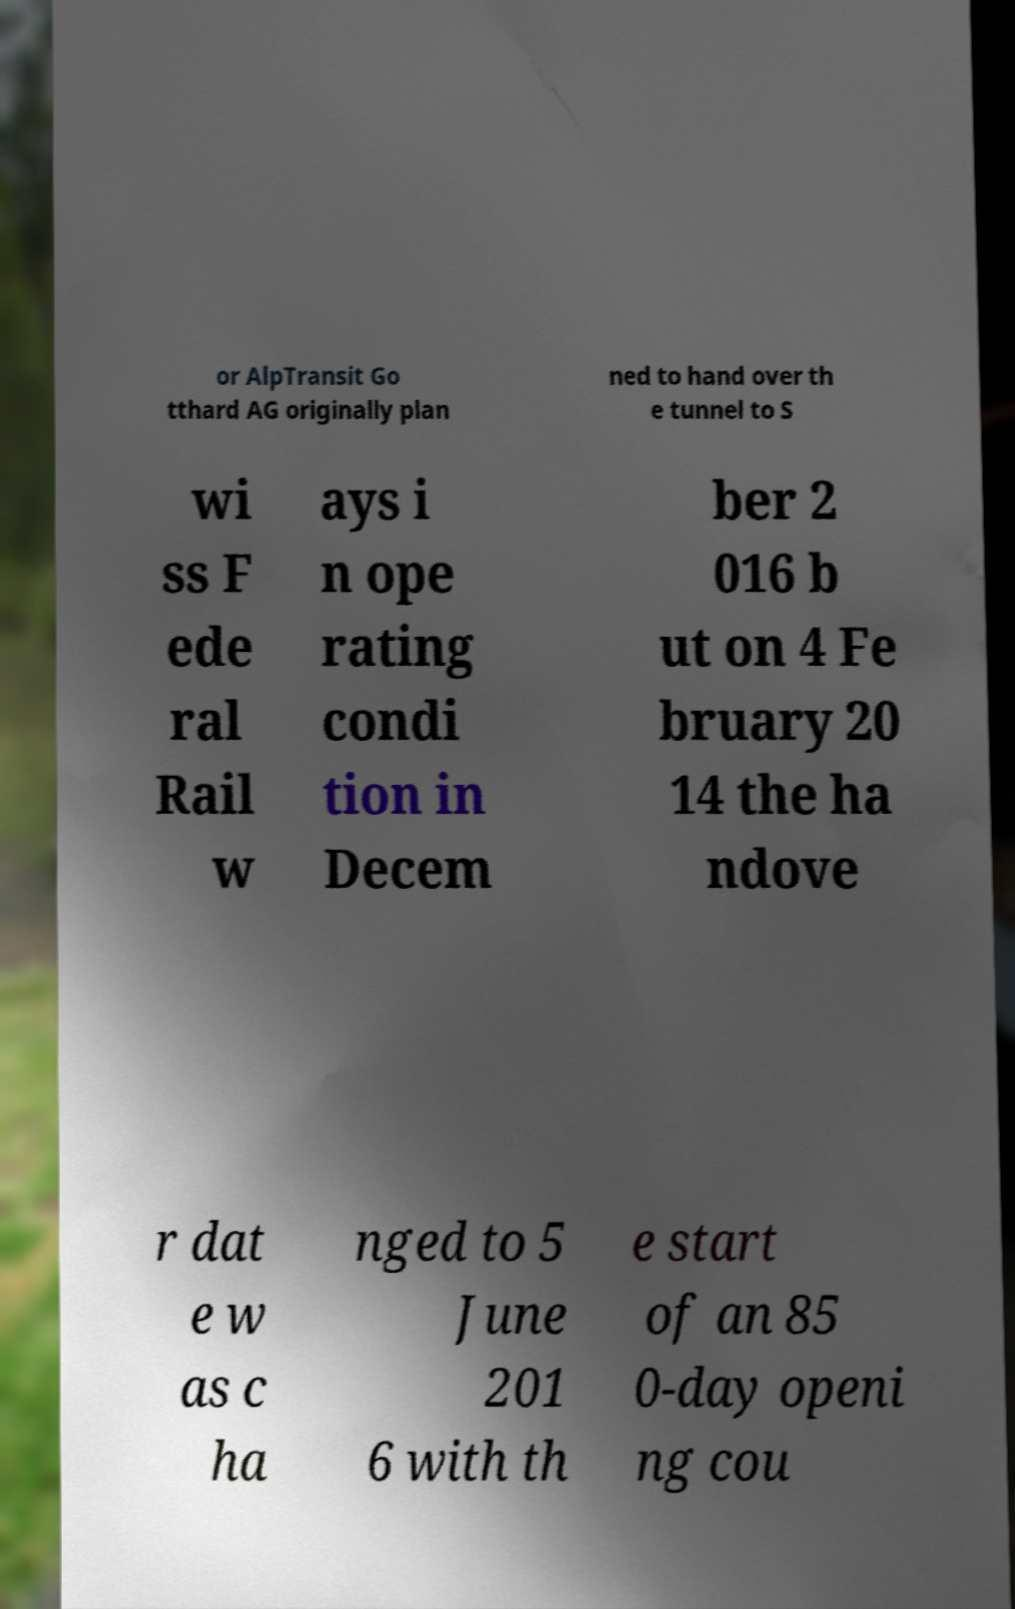I need the written content from this picture converted into text. Can you do that? or AlpTransit Go tthard AG originally plan ned to hand over th e tunnel to S wi ss F ede ral Rail w ays i n ope rating condi tion in Decem ber 2 016 b ut on 4 Fe bruary 20 14 the ha ndove r dat e w as c ha nged to 5 June 201 6 with th e start of an 85 0-day openi ng cou 